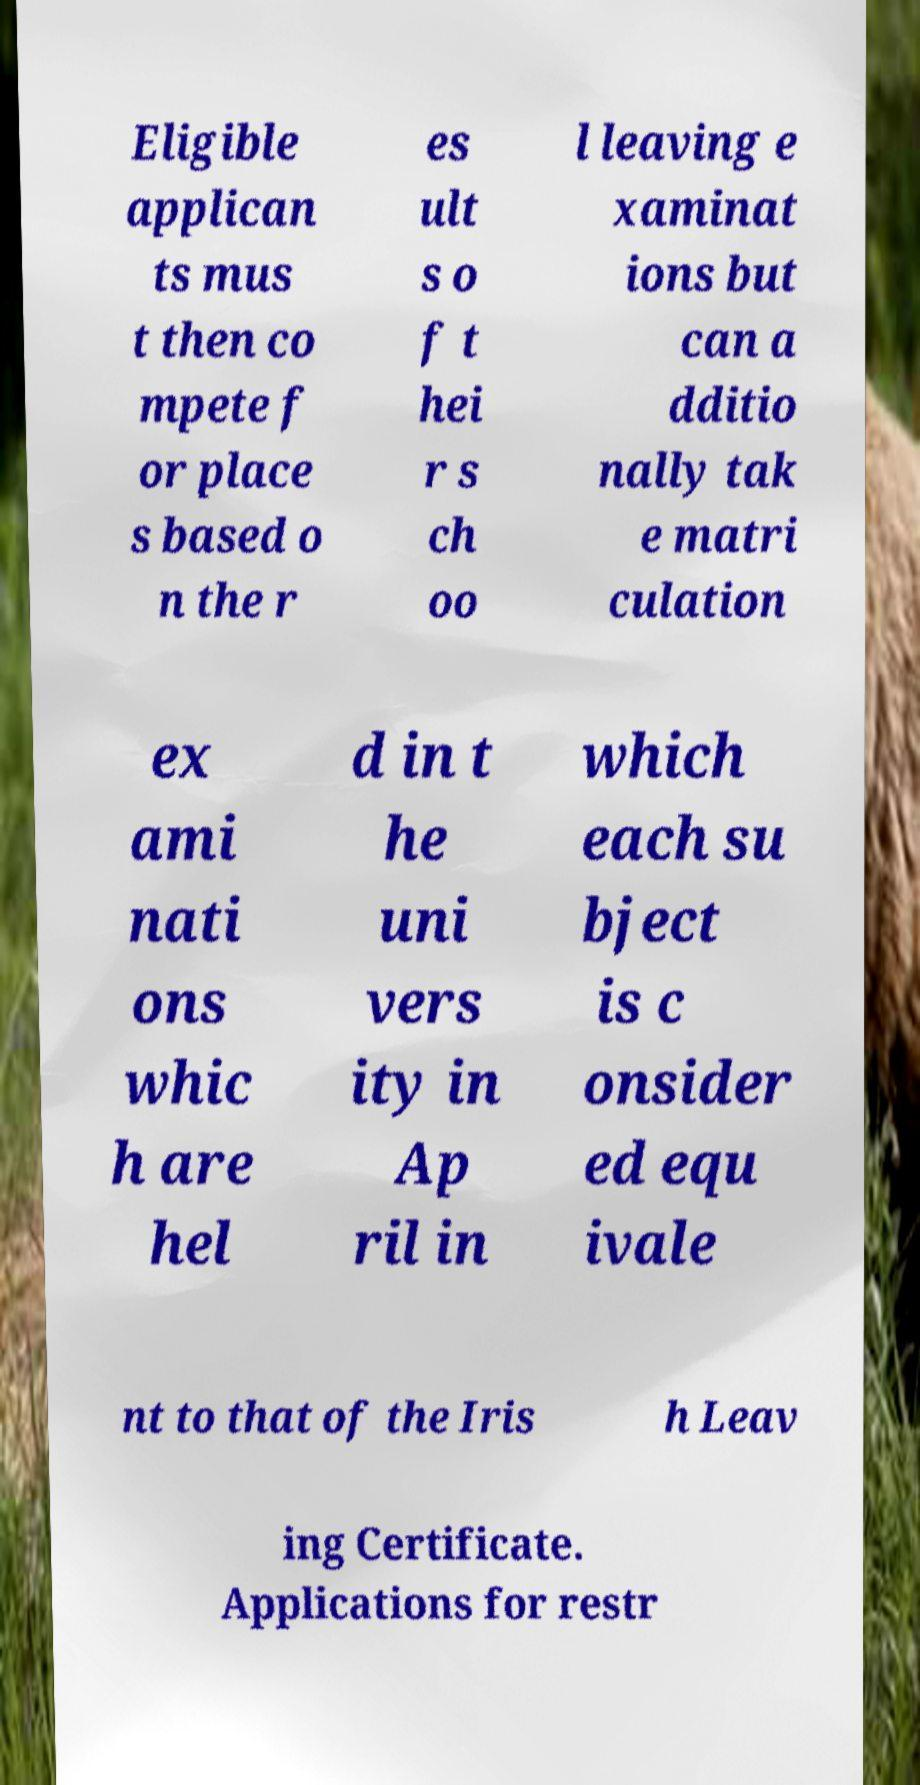Please read and relay the text visible in this image. What does it say? Eligible applican ts mus t then co mpete f or place s based o n the r es ult s o f t hei r s ch oo l leaving e xaminat ions but can a dditio nally tak e matri culation ex ami nati ons whic h are hel d in t he uni vers ity in Ap ril in which each su bject is c onsider ed equ ivale nt to that of the Iris h Leav ing Certificate. Applications for restr 